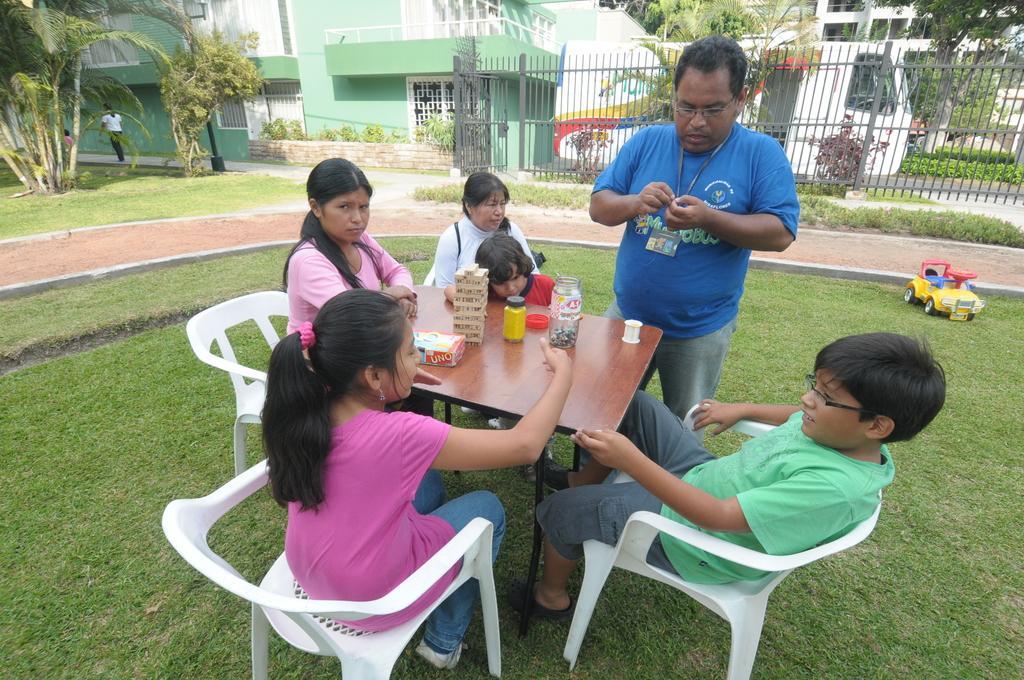Could you give a brief overview of what you see in this image? In this picture we can see man standing and remaining are sitting on chairs and in front of them there is table and on table we can see bottle, cap, box and in background we can see grass, trees, houses with windows , fence, vehicle, man walking on footpath. 